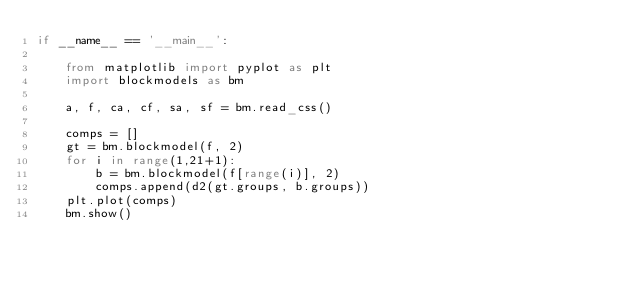<code> <loc_0><loc_0><loc_500><loc_500><_Python_>if __name__ == '__main__':

    from matplotlib import pyplot as plt
    import blockmodels as bm

    a, f, ca, cf, sa, sf = bm.read_css()

    comps = []
    gt = bm.blockmodel(f, 2)
    for i in range(1,21+1):
        b = bm.blockmodel(f[range(i)], 2)
        comps.append(d2(gt.groups, b.groups))
    plt.plot(comps)
    bm.show()
</code> 